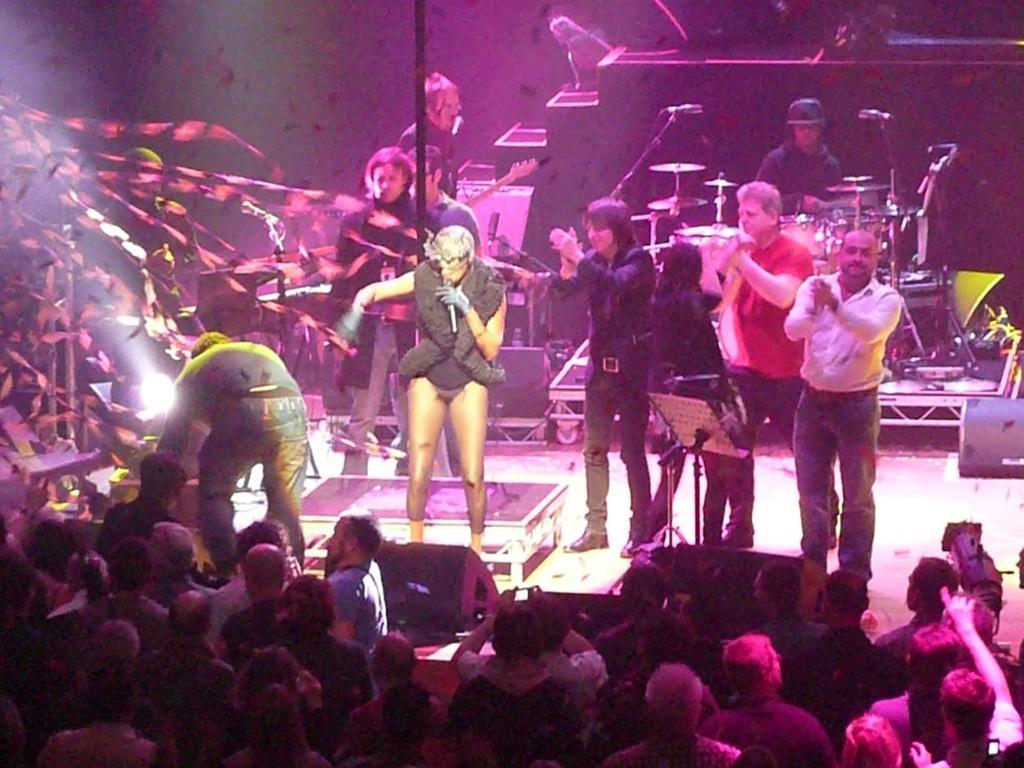In one or two sentences, can you explain what this image depicts? In the picture I can see people among them some are standing on the stage. I can also see one of them is holding a microphone in the hand. On the stage I can see musical instruments, stage lights and some other objects on the stage. 